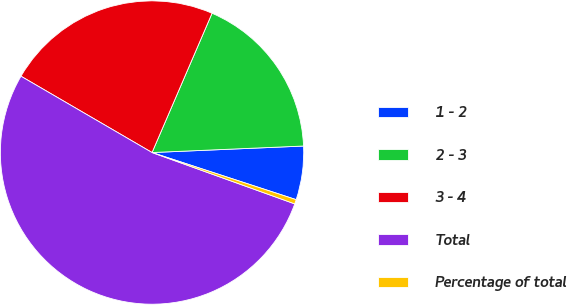Convert chart. <chart><loc_0><loc_0><loc_500><loc_500><pie_chart><fcel>1 - 2<fcel>2 - 3<fcel>3 - 4<fcel>Total<fcel>Percentage of total<nl><fcel>5.71%<fcel>17.84%<fcel>23.08%<fcel>52.89%<fcel>0.47%<nl></chart> 